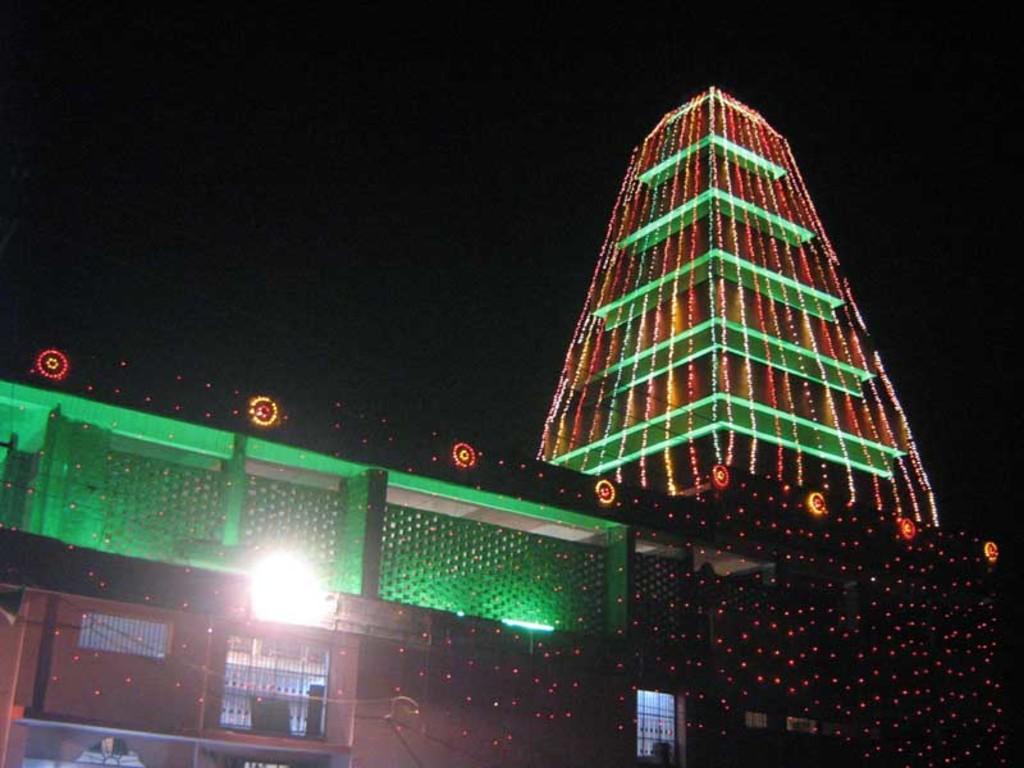How would you summarize this image in a sentence or two? In this image I can see a building with lights. There are iron grilles and there is a dark background. 